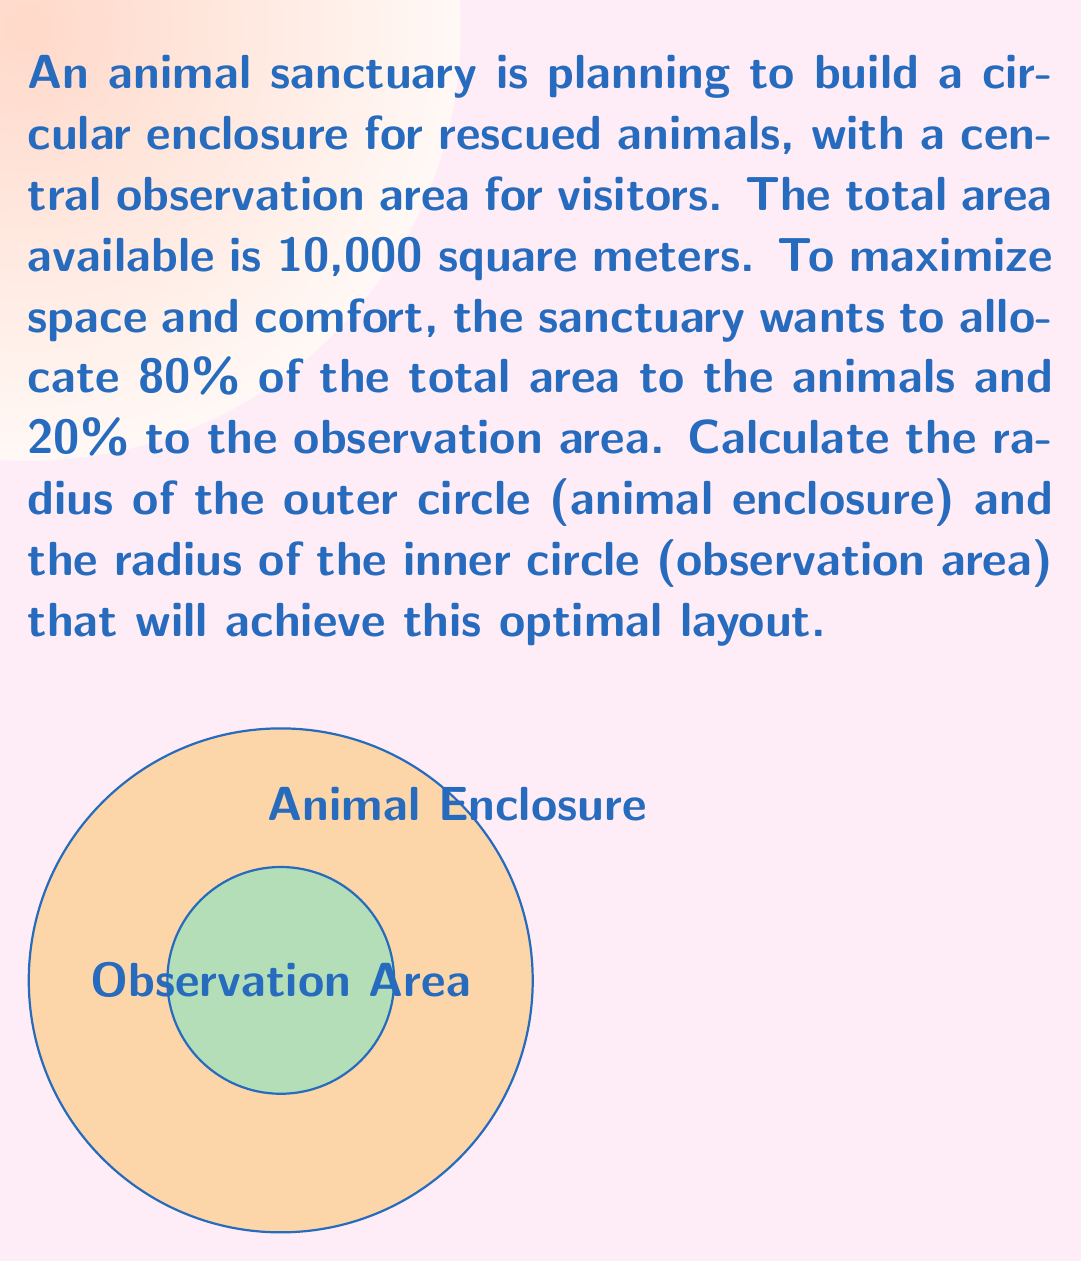Show me your answer to this math problem. Let's approach this step-by-step:

1) Let $R$ be the radius of the outer circle (animal enclosure) and $r$ be the radius of the inner circle (observation area).

2) The total area is 10,000 m², so:
   $$\pi R^2 = 10000$$

3) We want 80% for animals and 20% for observation. This means:
   Animal area = $0.8 \times 10000 = 8000$ m²
   Observation area = $0.2 \times 10000 = 2000$ m²

4) The area of the animal enclosure is the difference between the total area and the observation area:
   $$\pi R^2 - \pi r^2 = 8000$$

5) From step 2, we can find $R$:
   $$R = \sqrt{\frac{10000}{\pi}} \approx 56.42\text{ m}$$

6) Now we can find $r$ using the equation from step 4:
   $$\pi (56.42)^2 - \pi r^2 = 8000$$
   $$10000 - \pi r^2 = 8000$$
   $$\pi r^2 = 2000$$
   $$r = \sqrt{\frac{2000}{\pi}} \approx 25.23\text{ m}$$

7) Rounding to two decimal places:
   $R \approx 56.42\text{ m}$
   $r \approx 25.23\text{ m}$

This layout ensures that 80% of the total area is allocated to the animals and 20% to the observation area, maximizing space and comfort while maintaining the desired ratio.
Answer: $R \approx 56.42\text{ m}, r \approx 25.23\text{ m}$ 